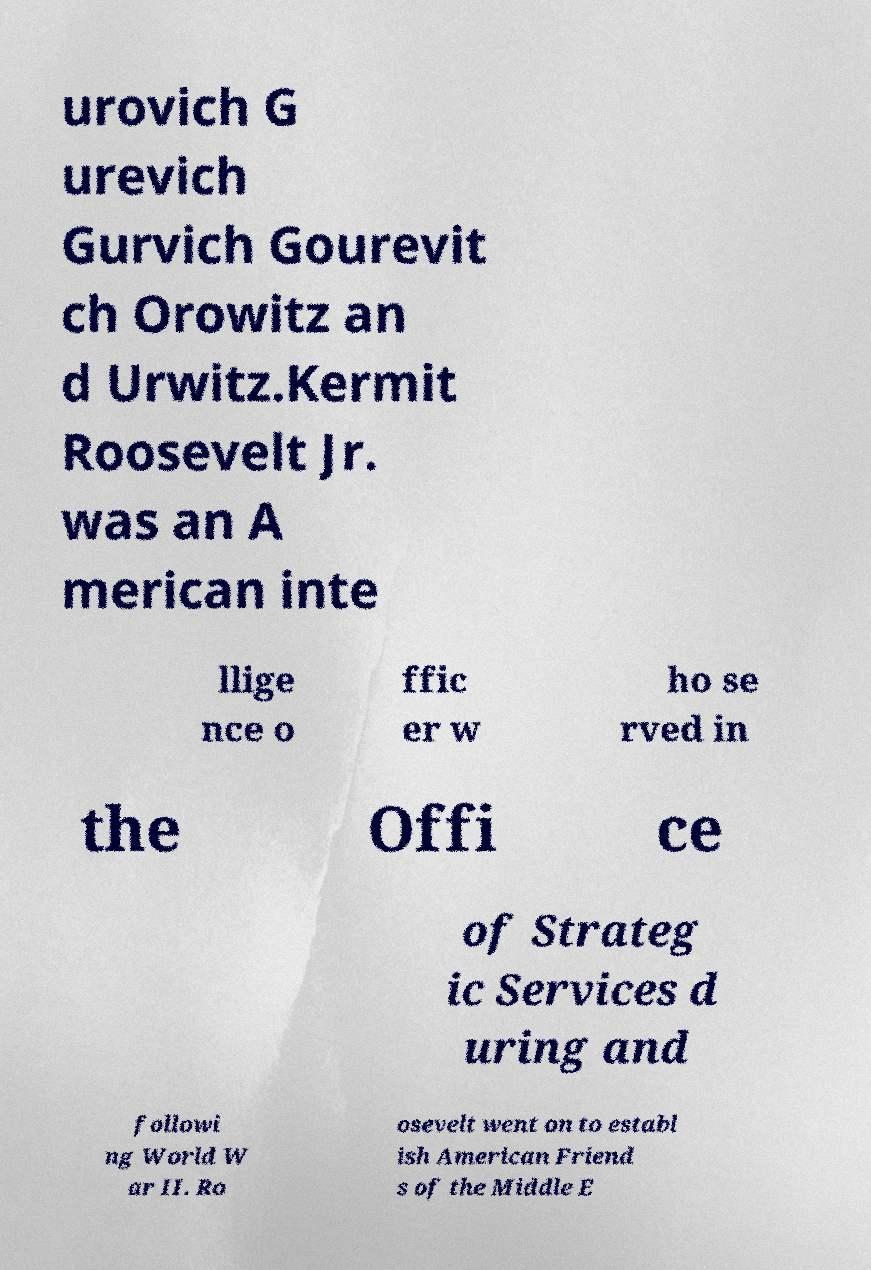Could you assist in decoding the text presented in this image and type it out clearly? urovich G urevich Gurvich Gourevit ch Orowitz an d Urwitz.Kermit Roosevelt Jr. was an A merican inte llige nce o ffic er w ho se rved in the Offi ce of Strateg ic Services d uring and followi ng World W ar II. Ro osevelt went on to establ ish American Friend s of the Middle E 